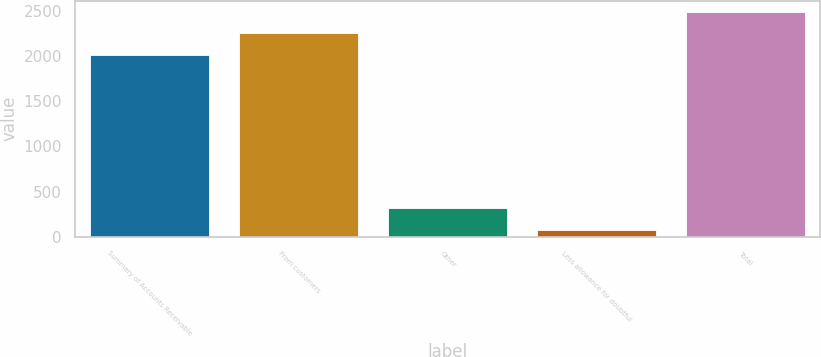Convert chart. <chart><loc_0><loc_0><loc_500><loc_500><bar_chart><fcel>Summary of Accounts Receivable<fcel>From customers<fcel>Other<fcel>Less allowance for doubtful<fcel>Total<nl><fcel>2010<fcel>2249.2<fcel>321<fcel>80<fcel>2488.4<nl></chart> 